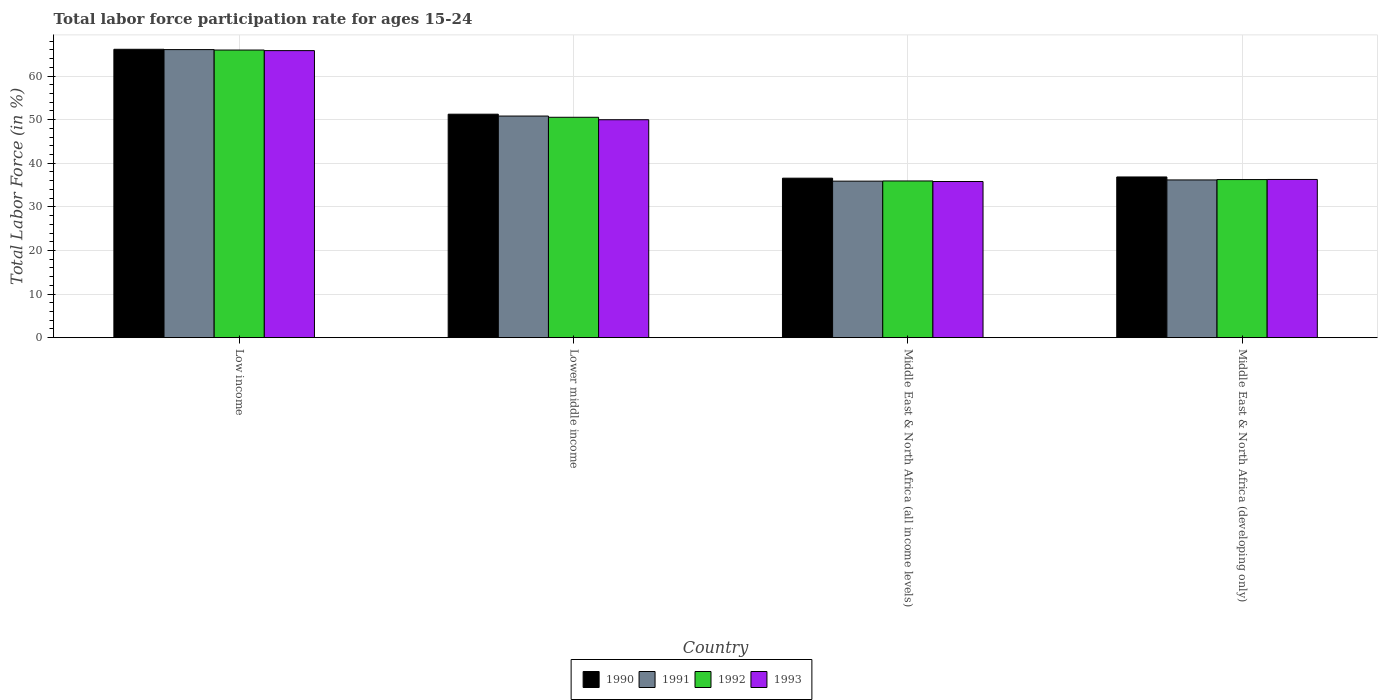How many different coloured bars are there?
Your answer should be very brief. 4. How many groups of bars are there?
Keep it short and to the point. 4. What is the label of the 2nd group of bars from the left?
Make the answer very short. Lower middle income. What is the labor force participation rate in 1993 in Low income?
Give a very brief answer. 65.82. Across all countries, what is the maximum labor force participation rate in 1990?
Your answer should be compact. 66.13. Across all countries, what is the minimum labor force participation rate in 1992?
Your response must be concise. 35.93. In which country was the labor force participation rate in 1992 maximum?
Provide a short and direct response. Low income. In which country was the labor force participation rate in 1993 minimum?
Ensure brevity in your answer.  Middle East & North Africa (all income levels). What is the total labor force participation rate in 1993 in the graph?
Provide a short and direct response. 187.88. What is the difference between the labor force participation rate in 1991 in Middle East & North Africa (all income levels) and that in Middle East & North Africa (developing only)?
Ensure brevity in your answer.  -0.28. What is the difference between the labor force participation rate in 1990 in Lower middle income and the labor force participation rate in 1991 in Middle East & North Africa (all income levels)?
Ensure brevity in your answer.  15.35. What is the average labor force participation rate in 1991 per country?
Make the answer very short. 47.23. What is the difference between the labor force participation rate of/in 1991 and labor force participation rate of/in 1992 in Low income?
Keep it short and to the point. 0.1. In how many countries, is the labor force participation rate in 1993 greater than 20 %?
Provide a succinct answer. 4. What is the ratio of the labor force participation rate in 1992 in Low income to that in Middle East & North Africa (developing only)?
Give a very brief answer. 1.82. Is the labor force participation rate in 1992 in Lower middle income less than that in Middle East & North Africa (developing only)?
Provide a short and direct response. No. What is the difference between the highest and the second highest labor force participation rate in 1990?
Ensure brevity in your answer.  14.88. What is the difference between the highest and the lowest labor force participation rate in 1992?
Ensure brevity in your answer.  30.02. Is it the case that in every country, the sum of the labor force participation rate in 1992 and labor force participation rate in 1993 is greater than the sum of labor force participation rate in 1990 and labor force participation rate in 1991?
Offer a terse response. No. How many bars are there?
Offer a very short reply. 16. How many countries are there in the graph?
Give a very brief answer. 4. What is the difference between two consecutive major ticks on the Y-axis?
Your response must be concise. 10. Does the graph contain any zero values?
Your answer should be compact. No. Does the graph contain grids?
Give a very brief answer. Yes. Where does the legend appear in the graph?
Your answer should be very brief. Bottom center. How many legend labels are there?
Give a very brief answer. 4. How are the legend labels stacked?
Your answer should be compact. Horizontal. What is the title of the graph?
Offer a very short reply. Total labor force participation rate for ages 15-24. What is the Total Labor Force (in %) of 1990 in Low income?
Make the answer very short. 66.13. What is the Total Labor Force (in %) of 1991 in Low income?
Offer a very short reply. 66.06. What is the Total Labor Force (in %) in 1992 in Low income?
Ensure brevity in your answer.  65.96. What is the Total Labor Force (in %) of 1993 in Low income?
Your response must be concise. 65.82. What is the Total Labor Force (in %) of 1990 in Lower middle income?
Make the answer very short. 51.24. What is the Total Labor Force (in %) of 1991 in Lower middle income?
Give a very brief answer. 50.82. What is the Total Labor Force (in %) of 1992 in Lower middle income?
Make the answer very short. 50.54. What is the Total Labor Force (in %) of 1993 in Lower middle income?
Offer a terse response. 49.98. What is the Total Labor Force (in %) of 1990 in Middle East & North Africa (all income levels)?
Your answer should be very brief. 36.57. What is the Total Labor Force (in %) in 1991 in Middle East & North Africa (all income levels)?
Keep it short and to the point. 35.89. What is the Total Labor Force (in %) in 1992 in Middle East & North Africa (all income levels)?
Your response must be concise. 35.93. What is the Total Labor Force (in %) in 1993 in Middle East & North Africa (all income levels)?
Provide a short and direct response. 35.81. What is the Total Labor Force (in %) of 1990 in Middle East & North Africa (developing only)?
Provide a short and direct response. 36.85. What is the Total Labor Force (in %) of 1991 in Middle East & North Africa (developing only)?
Offer a terse response. 36.17. What is the Total Labor Force (in %) of 1992 in Middle East & North Africa (developing only)?
Your answer should be compact. 36.25. What is the Total Labor Force (in %) in 1993 in Middle East & North Africa (developing only)?
Your answer should be very brief. 36.28. Across all countries, what is the maximum Total Labor Force (in %) in 1990?
Keep it short and to the point. 66.13. Across all countries, what is the maximum Total Labor Force (in %) in 1991?
Make the answer very short. 66.06. Across all countries, what is the maximum Total Labor Force (in %) in 1992?
Make the answer very short. 65.96. Across all countries, what is the maximum Total Labor Force (in %) in 1993?
Provide a succinct answer. 65.82. Across all countries, what is the minimum Total Labor Force (in %) of 1990?
Provide a short and direct response. 36.57. Across all countries, what is the minimum Total Labor Force (in %) in 1991?
Ensure brevity in your answer.  35.89. Across all countries, what is the minimum Total Labor Force (in %) of 1992?
Make the answer very short. 35.93. Across all countries, what is the minimum Total Labor Force (in %) of 1993?
Ensure brevity in your answer.  35.81. What is the total Total Labor Force (in %) in 1990 in the graph?
Offer a terse response. 190.79. What is the total Total Labor Force (in %) in 1991 in the graph?
Your answer should be very brief. 188.93. What is the total Total Labor Force (in %) of 1992 in the graph?
Offer a very short reply. 188.68. What is the total Total Labor Force (in %) in 1993 in the graph?
Your answer should be very brief. 187.88. What is the difference between the Total Labor Force (in %) in 1990 in Low income and that in Lower middle income?
Your answer should be compact. 14.88. What is the difference between the Total Labor Force (in %) of 1991 in Low income and that in Lower middle income?
Your answer should be very brief. 15.24. What is the difference between the Total Labor Force (in %) in 1992 in Low income and that in Lower middle income?
Make the answer very short. 15.42. What is the difference between the Total Labor Force (in %) of 1993 in Low income and that in Lower middle income?
Give a very brief answer. 15.85. What is the difference between the Total Labor Force (in %) of 1990 in Low income and that in Middle East & North Africa (all income levels)?
Provide a short and direct response. 29.55. What is the difference between the Total Labor Force (in %) in 1991 in Low income and that in Middle East & North Africa (all income levels)?
Provide a short and direct response. 30.17. What is the difference between the Total Labor Force (in %) in 1992 in Low income and that in Middle East & North Africa (all income levels)?
Make the answer very short. 30.02. What is the difference between the Total Labor Force (in %) of 1993 in Low income and that in Middle East & North Africa (all income levels)?
Provide a succinct answer. 30.02. What is the difference between the Total Labor Force (in %) of 1990 in Low income and that in Middle East & North Africa (developing only)?
Ensure brevity in your answer.  29.28. What is the difference between the Total Labor Force (in %) of 1991 in Low income and that in Middle East & North Africa (developing only)?
Offer a very short reply. 29.89. What is the difference between the Total Labor Force (in %) of 1992 in Low income and that in Middle East & North Africa (developing only)?
Your answer should be compact. 29.7. What is the difference between the Total Labor Force (in %) of 1993 in Low income and that in Middle East & North Africa (developing only)?
Give a very brief answer. 29.55. What is the difference between the Total Labor Force (in %) in 1990 in Lower middle income and that in Middle East & North Africa (all income levels)?
Your answer should be compact. 14.67. What is the difference between the Total Labor Force (in %) of 1991 in Lower middle income and that in Middle East & North Africa (all income levels)?
Give a very brief answer. 14.93. What is the difference between the Total Labor Force (in %) of 1992 in Lower middle income and that in Middle East & North Africa (all income levels)?
Provide a succinct answer. 14.6. What is the difference between the Total Labor Force (in %) of 1993 in Lower middle income and that in Middle East & North Africa (all income levels)?
Ensure brevity in your answer.  14.17. What is the difference between the Total Labor Force (in %) of 1990 in Lower middle income and that in Middle East & North Africa (developing only)?
Make the answer very short. 14.39. What is the difference between the Total Labor Force (in %) of 1991 in Lower middle income and that in Middle East & North Africa (developing only)?
Offer a very short reply. 14.65. What is the difference between the Total Labor Force (in %) of 1992 in Lower middle income and that in Middle East & North Africa (developing only)?
Your response must be concise. 14.28. What is the difference between the Total Labor Force (in %) of 1993 in Lower middle income and that in Middle East & North Africa (developing only)?
Your answer should be compact. 13.7. What is the difference between the Total Labor Force (in %) of 1990 in Middle East & North Africa (all income levels) and that in Middle East & North Africa (developing only)?
Offer a very short reply. -0.28. What is the difference between the Total Labor Force (in %) in 1991 in Middle East & North Africa (all income levels) and that in Middle East & North Africa (developing only)?
Give a very brief answer. -0.28. What is the difference between the Total Labor Force (in %) in 1992 in Middle East & North Africa (all income levels) and that in Middle East & North Africa (developing only)?
Your answer should be very brief. -0.32. What is the difference between the Total Labor Force (in %) of 1993 in Middle East & North Africa (all income levels) and that in Middle East & North Africa (developing only)?
Keep it short and to the point. -0.47. What is the difference between the Total Labor Force (in %) of 1990 in Low income and the Total Labor Force (in %) of 1991 in Lower middle income?
Keep it short and to the point. 15.31. What is the difference between the Total Labor Force (in %) of 1990 in Low income and the Total Labor Force (in %) of 1992 in Lower middle income?
Provide a short and direct response. 15.59. What is the difference between the Total Labor Force (in %) in 1990 in Low income and the Total Labor Force (in %) in 1993 in Lower middle income?
Your answer should be compact. 16.15. What is the difference between the Total Labor Force (in %) of 1991 in Low income and the Total Labor Force (in %) of 1992 in Lower middle income?
Your answer should be very brief. 15.52. What is the difference between the Total Labor Force (in %) in 1991 in Low income and the Total Labor Force (in %) in 1993 in Lower middle income?
Make the answer very short. 16.08. What is the difference between the Total Labor Force (in %) in 1992 in Low income and the Total Labor Force (in %) in 1993 in Lower middle income?
Your answer should be very brief. 15.98. What is the difference between the Total Labor Force (in %) in 1990 in Low income and the Total Labor Force (in %) in 1991 in Middle East & North Africa (all income levels)?
Your answer should be very brief. 30.24. What is the difference between the Total Labor Force (in %) in 1990 in Low income and the Total Labor Force (in %) in 1992 in Middle East & North Africa (all income levels)?
Offer a very short reply. 30.19. What is the difference between the Total Labor Force (in %) in 1990 in Low income and the Total Labor Force (in %) in 1993 in Middle East & North Africa (all income levels)?
Your answer should be very brief. 30.32. What is the difference between the Total Labor Force (in %) of 1991 in Low income and the Total Labor Force (in %) of 1992 in Middle East & North Africa (all income levels)?
Offer a terse response. 30.12. What is the difference between the Total Labor Force (in %) of 1991 in Low income and the Total Labor Force (in %) of 1993 in Middle East & North Africa (all income levels)?
Keep it short and to the point. 30.25. What is the difference between the Total Labor Force (in %) in 1992 in Low income and the Total Labor Force (in %) in 1993 in Middle East & North Africa (all income levels)?
Provide a succinct answer. 30.15. What is the difference between the Total Labor Force (in %) of 1990 in Low income and the Total Labor Force (in %) of 1991 in Middle East & North Africa (developing only)?
Your answer should be very brief. 29.96. What is the difference between the Total Labor Force (in %) in 1990 in Low income and the Total Labor Force (in %) in 1992 in Middle East & North Africa (developing only)?
Offer a terse response. 29.87. What is the difference between the Total Labor Force (in %) in 1990 in Low income and the Total Labor Force (in %) in 1993 in Middle East & North Africa (developing only)?
Make the answer very short. 29.85. What is the difference between the Total Labor Force (in %) in 1991 in Low income and the Total Labor Force (in %) in 1992 in Middle East & North Africa (developing only)?
Provide a succinct answer. 29.8. What is the difference between the Total Labor Force (in %) in 1991 in Low income and the Total Labor Force (in %) in 1993 in Middle East & North Africa (developing only)?
Ensure brevity in your answer.  29.78. What is the difference between the Total Labor Force (in %) in 1992 in Low income and the Total Labor Force (in %) in 1993 in Middle East & North Africa (developing only)?
Give a very brief answer. 29.68. What is the difference between the Total Labor Force (in %) of 1990 in Lower middle income and the Total Labor Force (in %) of 1991 in Middle East & North Africa (all income levels)?
Your answer should be very brief. 15.35. What is the difference between the Total Labor Force (in %) of 1990 in Lower middle income and the Total Labor Force (in %) of 1992 in Middle East & North Africa (all income levels)?
Your answer should be very brief. 15.31. What is the difference between the Total Labor Force (in %) in 1990 in Lower middle income and the Total Labor Force (in %) in 1993 in Middle East & North Africa (all income levels)?
Provide a short and direct response. 15.44. What is the difference between the Total Labor Force (in %) in 1991 in Lower middle income and the Total Labor Force (in %) in 1992 in Middle East & North Africa (all income levels)?
Keep it short and to the point. 14.88. What is the difference between the Total Labor Force (in %) of 1991 in Lower middle income and the Total Labor Force (in %) of 1993 in Middle East & North Africa (all income levels)?
Make the answer very short. 15.01. What is the difference between the Total Labor Force (in %) of 1992 in Lower middle income and the Total Labor Force (in %) of 1993 in Middle East & North Africa (all income levels)?
Your response must be concise. 14.73. What is the difference between the Total Labor Force (in %) of 1990 in Lower middle income and the Total Labor Force (in %) of 1991 in Middle East & North Africa (developing only)?
Your answer should be very brief. 15.07. What is the difference between the Total Labor Force (in %) of 1990 in Lower middle income and the Total Labor Force (in %) of 1992 in Middle East & North Africa (developing only)?
Provide a short and direct response. 14.99. What is the difference between the Total Labor Force (in %) in 1990 in Lower middle income and the Total Labor Force (in %) in 1993 in Middle East & North Africa (developing only)?
Make the answer very short. 14.96. What is the difference between the Total Labor Force (in %) of 1991 in Lower middle income and the Total Labor Force (in %) of 1992 in Middle East & North Africa (developing only)?
Your answer should be very brief. 14.56. What is the difference between the Total Labor Force (in %) in 1991 in Lower middle income and the Total Labor Force (in %) in 1993 in Middle East & North Africa (developing only)?
Your answer should be compact. 14.54. What is the difference between the Total Labor Force (in %) of 1992 in Lower middle income and the Total Labor Force (in %) of 1993 in Middle East & North Africa (developing only)?
Provide a succinct answer. 14.26. What is the difference between the Total Labor Force (in %) of 1990 in Middle East & North Africa (all income levels) and the Total Labor Force (in %) of 1991 in Middle East & North Africa (developing only)?
Provide a short and direct response. 0.4. What is the difference between the Total Labor Force (in %) of 1990 in Middle East & North Africa (all income levels) and the Total Labor Force (in %) of 1992 in Middle East & North Africa (developing only)?
Keep it short and to the point. 0.32. What is the difference between the Total Labor Force (in %) in 1990 in Middle East & North Africa (all income levels) and the Total Labor Force (in %) in 1993 in Middle East & North Africa (developing only)?
Provide a succinct answer. 0.29. What is the difference between the Total Labor Force (in %) in 1991 in Middle East & North Africa (all income levels) and the Total Labor Force (in %) in 1992 in Middle East & North Africa (developing only)?
Your answer should be very brief. -0.36. What is the difference between the Total Labor Force (in %) in 1991 in Middle East & North Africa (all income levels) and the Total Labor Force (in %) in 1993 in Middle East & North Africa (developing only)?
Provide a succinct answer. -0.39. What is the difference between the Total Labor Force (in %) of 1992 in Middle East & North Africa (all income levels) and the Total Labor Force (in %) of 1993 in Middle East & North Africa (developing only)?
Make the answer very short. -0.34. What is the average Total Labor Force (in %) of 1990 per country?
Provide a succinct answer. 47.7. What is the average Total Labor Force (in %) of 1991 per country?
Provide a short and direct response. 47.23. What is the average Total Labor Force (in %) in 1992 per country?
Your answer should be very brief. 47.17. What is the average Total Labor Force (in %) of 1993 per country?
Provide a succinct answer. 46.97. What is the difference between the Total Labor Force (in %) of 1990 and Total Labor Force (in %) of 1991 in Low income?
Ensure brevity in your answer.  0.07. What is the difference between the Total Labor Force (in %) of 1990 and Total Labor Force (in %) of 1992 in Low income?
Provide a succinct answer. 0.17. What is the difference between the Total Labor Force (in %) in 1990 and Total Labor Force (in %) in 1993 in Low income?
Provide a succinct answer. 0.3. What is the difference between the Total Labor Force (in %) of 1991 and Total Labor Force (in %) of 1992 in Low income?
Offer a terse response. 0.1. What is the difference between the Total Labor Force (in %) in 1991 and Total Labor Force (in %) in 1993 in Low income?
Your answer should be very brief. 0.23. What is the difference between the Total Labor Force (in %) of 1992 and Total Labor Force (in %) of 1993 in Low income?
Your response must be concise. 0.13. What is the difference between the Total Labor Force (in %) of 1990 and Total Labor Force (in %) of 1991 in Lower middle income?
Offer a very short reply. 0.43. What is the difference between the Total Labor Force (in %) of 1990 and Total Labor Force (in %) of 1992 in Lower middle income?
Your answer should be very brief. 0.71. What is the difference between the Total Labor Force (in %) in 1990 and Total Labor Force (in %) in 1993 in Lower middle income?
Provide a short and direct response. 1.27. What is the difference between the Total Labor Force (in %) in 1991 and Total Labor Force (in %) in 1992 in Lower middle income?
Keep it short and to the point. 0.28. What is the difference between the Total Labor Force (in %) in 1991 and Total Labor Force (in %) in 1993 in Lower middle income?
Your answer should be very brief. 0.84. What is the difference between the Total Labor Force (in %) of 1992 and Total Labor Force (in %) of 1993 in Lower middle income?
Provide a succinct answer. 0.56. What is the difference between the Total Labor Force (in %) in 1990 and Total Labor Force (in %) in 1991 in Middle East & North Africa (all income levels)?
Your answer should be compact. 0.68. What is the difference between the Total Labor Force (in %) in 1990 and Total Labor Force (in %) in 1992 in Middle East & North Africa (all income levels)?
Provide a succinct answer. 0.64. What is the difference between the Total Labor Force (in %) of 1990 and Total Labor Force (in %) of 1993 in Middle East & North Africa (all income levels)?
Provide a short and direct response. 0.76. What is the difference between the Total Labor Force (in %) in 1991 and Total Labor Force (in %) in 1992 in Middle East & North Africa (all income levels)?
Ensure brevity in your answer.  -0.05. What is the difference between the Total Labor Force (in %) in 1991 and Total Labor Force (in %) in 1993 in Middle East & North Africa (all income levels)?
Ensure brevity in your answer.  0.08. What is the difference between the Total Labor Force (in %) in 1992 and Total Labor Force (in %) in 1993 in Middle East & North Africa (all income levels)?
Keep it short and to the point. 0.13. What is the difference between the Total Labor Force (in %) of 1990 and Total Labor Force (in %) of 1991 in Middle East & North Africa (developing only)?
Provide a succinct answer. 0.68. What is the difference between the Total Labor Force (in %) in 1990 and Total Labor Force (in %) in 1992 in Middle East & North Africa (developing only)?
Ensure brevity in your answer.  0.6. What is the difference between the Total Labor Force (in %) in 1990 and Total Labor Force (in %) in 1993 in Middle East & North Africa (developing only)?
Keep it short and to the point. 0.57. What is the difference between the Total Labor Force (in %) in 1991 and Total Labor Force (in %) in 1992 in Middle East & North Africa (developing only)?
Ensure brevity in your answer.  -0.08. What is the difference between the Total Labor Force (in %) in 1991 and Total Labor Force (in %) in 1993 in Middle East & North Africa (developing only)?
Offer a very short reply. -0.11. What is the difference between the Total Labor Force (in %) in 1992 and Total Labor Force (in %) in 1993 in Middle East & North Africa (developing only)?
Your answer should be very brief. -0.02. What is the ratio of the Total Labor Force (in %) in 1990 in Low income to that in Lower middle income?
Your answer should be compact. 1.29. What is the ratio of the Total Labor Force (in %) in 1991 in Low income to that in Lower middle income?
Provide a succinct answer. 1.3. What is the ratio of the Total Labor Force (in %) in 1992 in Low income to that in Lower middle income?
Offer a terse response. 1.31. What is the ratio of the Total Labor Force (in %) in 1993 in Low income to that in Lower middle income?
Provide a succinct answer. 1.32. What is the ratio of the Total Labor Force (in %) in 1990 in Low income to that in Middle East & North Africa (all income levels)?
Keep it short and to the point. 1.81. What is the ratio of the Total Labor Force (in %) of 1991 in Low income to that in Middle East & North Africa (all income levels)?
Your answer should be very brief. 1.84. What is the ratio of the Total Labor Force (in %) in 1992 in Low income to that in Middle East & North Africa (all income levels)?
Your answer should be very brief. 1.84. What is the ratio of the Total Labor Force (in %) of 1993 in Low income to that in Middle East & North Africa (all income levels)?
Provide a succinct answer. 1.84. What is the ratio of the Total Labor Force (in %) in 1990 in Low income to that in Middle East & North Africa (developing only)?
Your answer should be very brief. 1.79. What is the ratio of the Total Labor Force (in %) of 1991 in Low income to that in Middle East & North Africa (developing only)?
Ensure brevity in your answer.  1.83. What is the ratio of the Total Labor Force (in %) in 1992 in Low income to that in Middle East & North Africa (developing only)?
Ensure brevity in your answer.  1.82. What is the ratio of the Total Labor Force (in %) of 1993 in Low income to that in Middle East & North Africa (developing only)?
Keep it short and to the point. 1.81. What is the ratio of the Total Labor Force (in %) of 1990 in Lower middle income to that in Middle East & North Africa (all income levels)?
Give a very brief answer. 1.4. What is the ratio of the Total Labor Force (in %) of 1991 in Lower middle income to that in Middle East & North Africa (all income levels)?
Provide a succinct answer. 1.42. What is the ratio of the Total Labor Force (in %) in 1992 in Lower middle income to that in Middle East & North Africa (all income levels)?
Keep it short and to the point. 1.41. What is the ratio of the Total Labor Force (in %) of 1993 in Lower middle income to that in Middle East & North Africa (all income levels)?
Your answer should be very brief. 1.4. What is the ratio of the Total Labor Force (in %) in 1990 in Lower middle income to that in Middle East & North Africa (developing only)?
Ensure brevity in your answer.  1.39. What is the ratio of the Total Labor Force (in %) in 1991 in Lower middle income to that in Middle East & North Africa (developing only)?
Ensure brevity in your answer.  1.41. What is the ratio of the Total Labor Force (in %) of 1992 in Lower middle income to that in Middle East & North Africa (developing only)?
Offer a terse response. 1.39. What is the ratio of the Total Labor Force (in %) in 1993 in Lower middle income to that in Middle East & North Africa (developing only)?
Provide a succinct answer. 1.38. What is the ratio of the Total Labor Force (in %) of 1991 in Middle East & North Africa (all income levels) to that in Middle East & North Africa (developing only)?
Offer a very short reply. 0.99. What is the ratio of the Total Labor Force (in %) in 1992 in Middle East & North Africa (all income levels) to that in Middle East & North Africa (developing only)?
Your response must be concise. 0.99. What is the ratio of the Total Labor Force (in %) of 1993 in Middle East & North Africa (all income levels) to that in Middle East & North Africa (developing only)?
Give a very brief answer. 0.99. What is the difference between the highest and the second highest Total Labor Force (in %) in 1990?
Make the answer very short. 14.88. What is the difference between the highest and the second highest Total Labor Force (in %) in 1991?
Your response must be concise. 15.24. What is the difference between the highest and the second highest Total Labor Force (in %) of 1992?
Provide a short and direct response. 15.42. What is the difference between the highest and the second highest Total Labor Force (in %) of 1993?
Offer a very short reply. 15.85. What is the difference between the highest and the lowest Total Labor Force (in %) of 1990?
Your answer should be compact. 29.55. What is the difference between the highest and the lowest Total Labor Force (in %) of 1991?
Your answer should be very brief. 30.17. What is the difference between the highest and the lowest Total Labor Force (in %) of 1992?
Your answer should be compact. 30.02. What is the difference between the highest and the lowest Total Labor Force (in %) in 1993?
Offer a terse response. 30.02. 